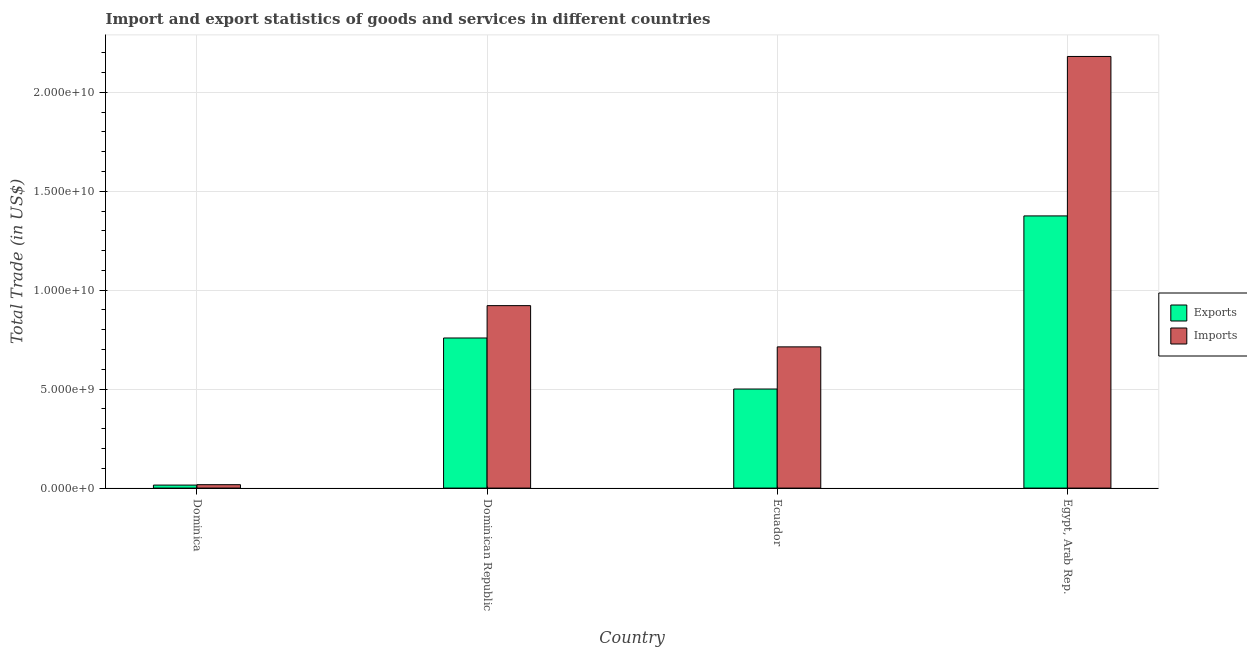How many bars are there on the 1st tick from the left?
Offer a very short reply. 2. How many bars are there on the 4th tick from the right?
Offer a terse response. 2. What is the label of the 2nd group of bars from the left?
Keep it short and to the point. Dominican Republic. In how many cases, is the number of bars for a given country not equal to the number of legend labels?
Keep it short and to the point. 0. What is the imports of goods and services in Ecuador?
Keep it short and to the point. 7.14e+09. Across all countries, what is the maximum imports of goods and services?
Offer a very short reply. 2.18e+1. Across all countries, what is the minimum export of goods and services?
Your response must be concise. 1.52e+08. In which country was the imports of goods and services maximum?
Ensure brevity in your answer.  Egypt, Arab Rep. In which country was the imports of goods and services minimum?
Give a very brief answer. Dominica. What is the total export of goods and services in the graph?
Offer a very short reply. 2.65e+1. What is the difference between the imports of goods and services in Dominica and that in Ecuador?
Keep it short and to the point. -6.96e+09. What is the difference between the imports of goods and services in Dominica and the export of goods and services in Egypt, Arab Rep.?
Provide a short and direct response. -1.36e+1. What is the average export of goods and services per country?
Your response must be concise. 6.62e+09. What is the difference between the imports of goods and services and export of goods and services in Dominican Republic?
Keep it short and to the point. 1.64e+09. In how many countries, is the imports of goods and services greater than 7000000000 US$?
Your response must be concise. 3. What is the ratio of the export of goods and services in Dominica to that in Egypt, Arab Rep.?
Provide a short and direct response. 0.01. Is the imports of goods and services in Dominican Republic less than that in Ecuador?
Provide a short and direct response. No. What is the difference between the highest and the second highest imports of goods and services?
Offer a very short reply. 1.26e+1. What is the difference between the highest and the lowest export of goods and services?
Your response must be concise. 1.36e+1. In how many countries, is the export of goods and services greater than the average export of goods and services taken over all countries?
Provide a short and direct response. 2. What does the 2nd bar from the left in Dominican Republic represents?
Give a very brief answer. Imports. What does the 1st bar from the right in Egypt, Arab Rep. represents?
Your answer should be very brief. Imports. How many bars are there?
Provide a short and direct response. 8. How many countries are there in the graph?
Your response must be concise. 4. Are the values on the major ticks of Y-axis written in scientific E-notation?
Your answer should be compact. Yes. Does the graph contain any zero values?
Provide a succinct answer. No. Where does the legend appear in the graph?
Offer a very short reply. Center right. How many legend labels are there?
Your response must be concise. 2. What is the title of the graph?
Ensure brevity in your answer.  Import and export statistics of goods and services in different countries. What is the label or title of the Y-axis?
Your answer should be compact. Total Trade (in US$). What is the Total Trade (in US$) in Exports in Dominica?
Your answer should be very brief. 1.52e+08. What is the Total Trade (in US$) of Imports in Dominica?
Your answer should be compact. 1.72e+08. What is the Total Trade (in US$) in Exports in Dominican Republic?
Offer a very short reply. 7.59e+09. What is the Total Trade (in US$) in Imports in Dominican Republic?
Keep it short and to the point. 9.22e+09. What is the Total Trade (in US$) of Exports in Ecuador?
Your answer should be compact. 5.01e+09. What is the Total Trade (in US$) of Imports in Ecuador?
Your answer should be compact. 7.14e+09. What is the Total Trade (in US$) in Exports in Egypt, Arab Rep.?
Provide a succinct answer. 1.38e+1. What is the Total Trade (in US$) in Imports in Egypt, Arab Rep.?
Make the answer very short. 2.18e+1. Across all countries, what is the maximum Total Trade (in US$) in Exports?
Make the answer very short. 1.38e+1. Across all countries, what is the maximum Total Trade (in US$) of Imports?
Provide a short and direct response. 2.18e+1. Across all countries, what is the minimum Total Trade (in US$) of Exports?
Give a very brief answer. 1.52e+08. Across all countries, what is the minimum Total Trade (in US$) in Imports?
Offer a terse response. 1.72e+08. What is the total Total Trade (in US$) in Exports in the graph?
Offer a very short reply. 2.65e+1. What is the total Total Trade (in US$) in Imports in the graph?
Provide a succinct answer. 3.83e+1. What is the difference between the Total Trade (in US$) of Exports in Dominica and that in Dominican Republic?
Offer a terse response. -7.43e+09. What is the difference between the Total Trade (in US$) in Imports in Dominica and that in Dominican Republic?
Give a very brief answer. -9.05e+09. What is the difference between the Total Trade (in US$) in Exports in Dominica and that in Ecuador?
Provide a short and direct response. -4.85e+09. What is the difference between the Total Trade (in US$) of Imports in Dominica and that in Ecuador?
Keep it short and to the point. -6.96e+09. What is the difference between the Total Trade (in US$) of Exports in Dominica and that in Egypt, Arab Rep.?
Your answer should be compact. -1.36e+1. What is the difference between the Total Trade (in US$) in Imports in Dominica and that in Egypt, Arab Rep.?
Keep it short and to the point. -2.16e+1. What is the difference between the Total Trade (in US$) of Exports in Dominican Republic and that in Ecuador?
Offer a terse response. 2.58e+09. What is the difference between the Total Trade (in US$) in Imports in Dominican Republic and that in Ecuador?
Give a very brief answer. 2.08e+09. What is the difference between the Total Trade (in US$) in Exports in Dominican Republic and that in Egypt, Arab Rep.?
Your answer should be compact. -6.17e+09. What is the difference between the Total Trade (in US$) of Imports in Dominican Republic and that in Egypt, Arab Rep.?
Give a very brief answer. -1.26e+1. What is the difference between the Total Trade (in US$) of Exports in Ecuador and that in Egypt, Arab Rep.?
Your answer should be compact. -8.75e+09. What is the difference between the Total Trade (in US$) in Imports in Ecuador and that in Egypt, Arab Rep.?
Give a very brief answer. -1.47e+1. What is the difference between the Total Trade (in US$) of Exports in Dominica and the Total Trade (in US$) of Imports in Dominican Republic?
Your response must be concise. -9.07e+09. What is the difference between the Total Trade (in US$) in Exports in Dominica and the Total Trade (in US$) in Imports in Ecuador?
Your answer should be compact. -6.98e+09. What is the difference between the Total Trade (in US$) of Exports in Dominica and the Total Trade (in US$) of Imports in Egypt, Arab Rep.?
Keep it short and to the point. -2.17e+1. What is the difference between the Total Trade (in US$) of Exports in Dominican Republic and the Total Trade (in US$) of Imports in Ecuador?
Offer a terse response. 4.49e+08. What is the difference between the Total Trade (in US$) of Exports in Dominican Republic and the Total Trade (in US$) of Imports in Egypt, Arab Rep.?
Make the answer very short. -1.42e+1. What is the difference between the Total Trade (in US$) of Exports in Ecuador and the Total Trade (in US$) of Imports in Egypt, Arab Rep.?
Offer a very short reply. -1.68e+1. What is the average Total Trade (in US$) of Exports per country?
Ensure brevity in your answer.  6.62e+09. What is the average Total Trade (in US$) of Imports per country?
Keep it short and to the point. 9.59e+09. What is the difference between the Total Trade (in US$) in Exports and Total Trade (in US$) in Imports in Dominica?
Make the answer very short. -2.06e+07. What is the difference between the Total Trade (in US$) of Exports and Total Trade (in US$) of Imports in Dominican Republic?
Give a very brief answer. -1.64e+09. What is the difference between the Total Trade (in US$) in Exports and Total Trade (in US$) in Imports in Ecuador?
Make the answer very short. -2.13e+09. What is the difference between the Total Trade (in US$) of Exports and Total Trade (in US$) of Imports in Egypt, Arab Rep.?
Your answer should be very brief. -8.06e+09. What is the ratio of the Total Trade (in US$) of Imports in Dominica to that in Dominican Republic?
Provide a short and direct response. 0.02. What is the ratio of the Total Trade (in US$) of Exports in Dominica to that in Ecuador?
Give a very brief answer. 0.03. What is the ratio of the Total Trade (in US$) in Imports in Dominica to that in Ecuador?
Give a very brief answer. 0.02. What is the ratio of the Total Trade (in US$) in Exports in Dominica to that in Egypt, Arab Rep.?
Offer a terse response. 0.01. What is the ratio of the Total Trade (in US$) in Imports in Dominica to that in Egypt, Arab Rep.?
Your answer should be compact. 0.01. What is the ratio of the Total Trade (in US$) of Exports in Dominican Republic to that in Ecuador?
Provide a short and direct response. 1.51. What is the ratio of the Total Trade (in US$) in Imports in Dominican Republic to that in Ecuador?
Your answer should be very brief. 1.29. What is the ratio of the Total Trade (in US$) of Exports in Dominican Republic to that in Egypt, Arab Rep.?
Offer a very short reply. 0.55. What is the ratio of the Total Trade (in US$) in Imports in Dominican Republic to that in Egypt, Arab Rep.?
Provide a short and direct response. 0.42. What is the ratio of the Total Trade (in US$) in Exports in Ecuador to that in Egypt, Arab Rep.?
Your answer should be compact. 0.36. What is the ratio of the Total Trade (in US$) of Imports in Ecuador to that in Egypt, Arab Rep.?
Make the answer very short. 0.33. What is the difference between the highest and the second highest Total Trade (in US$) of Exports?
Provide a succinct answer. 6.17e+09. What is the difference between the highest and the second highest Total Trade (in US$) in Imports?
Provide a succinct answer. 1.26e+1. What is the difference between the highest and the lowest Total Trade (in US$) in Exports?
Make the answer very short. 1.36e+1. What is the difference between the highest and the lowest Total Trade (in US$) of Imports?
Keep it short and to the point. 2.16e+1. 